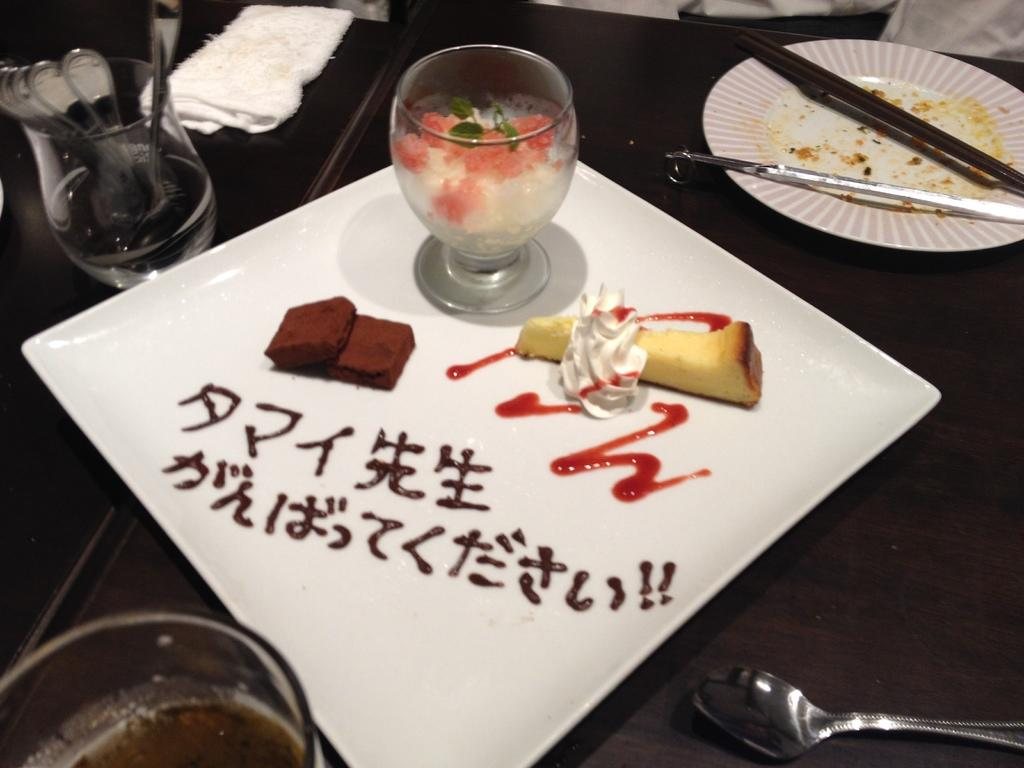What piece of furniture is present in the image? There is a table in the image. What items can be seen on the table? There are glasses, a plate, spoons, and food visible on the table. What might be used for eating or drinking with the food and drinks on the table? The spoons on the table can be used for eating or drinking. What is written on the table using paste? There is something written with paste on the table. What type of ocean can be seen in the image? There is no ocean present in the image; it features a table with various items on it. Can you describe the clouds in the image? There are no clouds present in the image. 